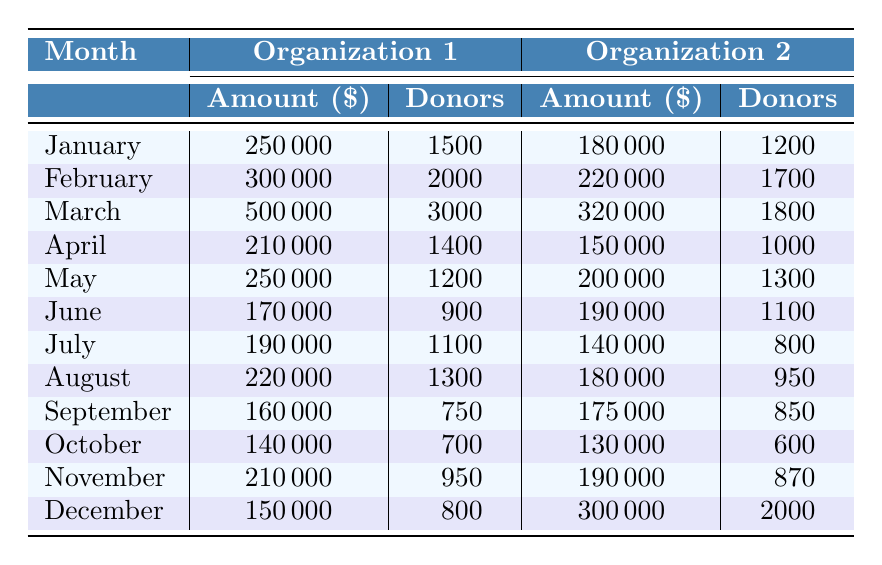What was the organization with the highest donation in March? The table shows that in March, "Black Lives Matter" received $500,000, which is the highest amount in that month.
Answer: Black Lives Matter How many donors contributed to the ACLU in January? According to the table, the ACLU had 1,500 donors in January.
Answer: 1500 Which month saw the lowest total amount donated between the two organizations? By looking at the amounts for each month, September has the lowest total donation of $335,000 ($160,000 + $175,000).
Answer: September What is the total amount donated to social justice organizations in February? In February, the total donation was $300,000 (Human Rights Campaign) + $220,000 (Planned Parenthood) = $520,000.
Answer: $520,000 Did the amount donated to the Women’s Refugee Commission exceed $170,000 in August? The table shows that the donation to Women's Refugee Commission in August was $180,000, so yes, it did exceed $170,000.
Answer: Yes Which organization had the highest number of donors in December? In December, "Human Rights Watch" had 2,000 donors, which is the highest number in that month compared to the World Wildlife Fund's 800.
Answer: Human Rights Watch What was the average amount donated for all organizations in July? The total donations in July were $190,000 + $140,000 = $330,000. There are 2 organizations, so the average is $330,000 / 2 = $165,000.
Answer: $165,000 How much more were the donations in March compared to June? In March, donations totaled $820,000, while in June they totaled $360,000. The difference is $820,000 - $360,000 = $460,000.
Answer: $460,000 Which month had the second highest number of donors across both organizations? March had the highest number of donors (3,000 + 1,800 = 4,800), while June had 2,000 by combining both organizations, making June the second highest.
Answer: June Are the total donations from both organizations in October greater than $300,000? The total donations in October were $140,000 + $130,000 = $270,000, which is less than $300,000.
Answer: No 